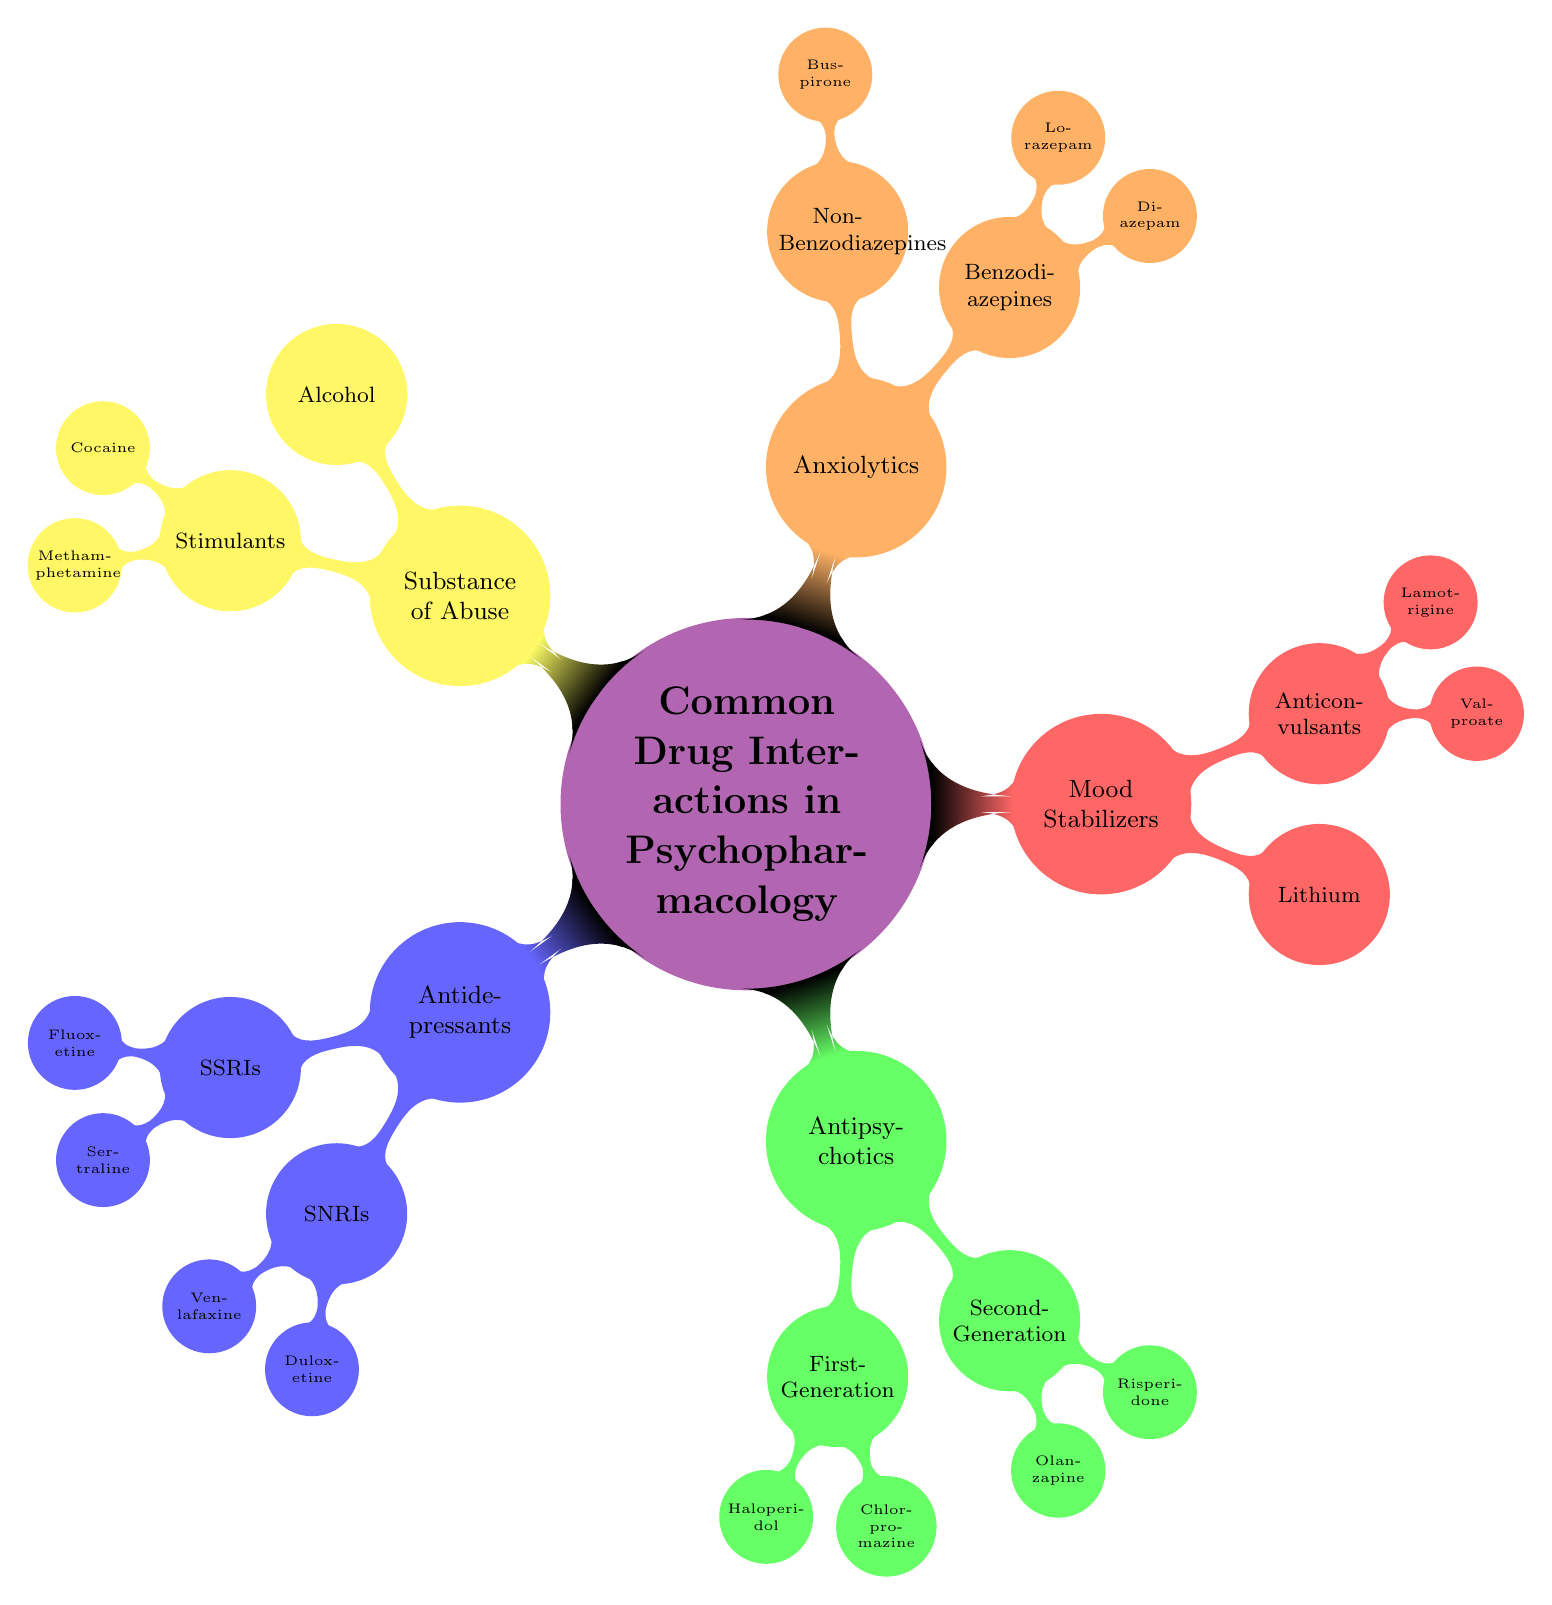What are the two categories under Antidepressants? The diagram shows two categories under Antidepressants: SSRIs and SNRIs. These represent different classes of antidepressant medications.
Answer: SSRIs, SNRIs How many Second-Generation antipsychotics are listed? The diagram displays two Second-Generation antipsychotics: Olanzapine and Risperidone. Therefore, the number listed is two.
Answer: 2 Which substance of abuse is mentioned without any additional categories? The diagram lists Alcohol as a specific substance of abuse that does not have subcategories or additional nodes beneath it.
Answer: Alcohol What is one example of a Benzodiazepine listed? Within the Anxiolytics section, Diazepam is identified as one of the examples of Benzodiazepines.
Answer: Diazepam Which Mood Stabilizer is a form of Anticonvulsant? The diagram indicates that Valproate is listed under Anticonvulsants within the Mood Stabilizers category, thus making it an Anticonvulsant mood stabilizer.
Answer: Valproate What is the meaning of the node "Common Drug Interactions in Psychopharmacology"? This is the central concept of the mind map, which encompasses the various drugs and potential interactions pertinent to psychopharmacology. It serves as the main topic that branches into various classes of medications and substances.
Answer: Central topic How many total primary categories are displayed in the mind map? The diagram reveals five primary categories: Antidepressants, Antipsychotics, Mood Stabilizers, Anxiolytics, and Substance of Abuse, leading to a total count of five.
Answer: 5 What are the two types listed under Anxiolytics? The two types under Anxiolytics mentioned in the diagram are Benzodiazepines and Non-Benzodiazepines, indicating different classes of anxiolytic medications.
Answer: Benzodiazepines, Non-Benzodiazepines Which First-Generation antipsychotic is listed? The diagram outlines Haloperidol and Chlorpromazine as examples of First-Generation antipsychotics, so either can be considered a valid response to the question.
Answer: Haloperidol 